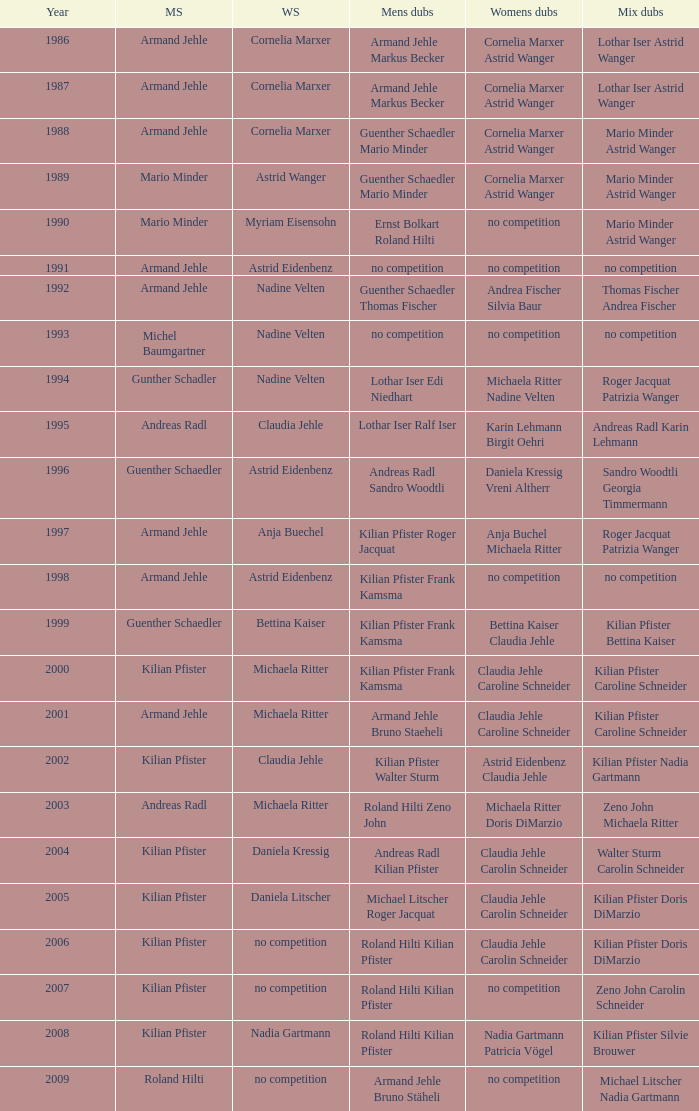In 2001, where the mens singles is armand jehle and the womens singles is michaela ritter, who are the mixed doubles Kilian Pfister Caroline Schneider. 